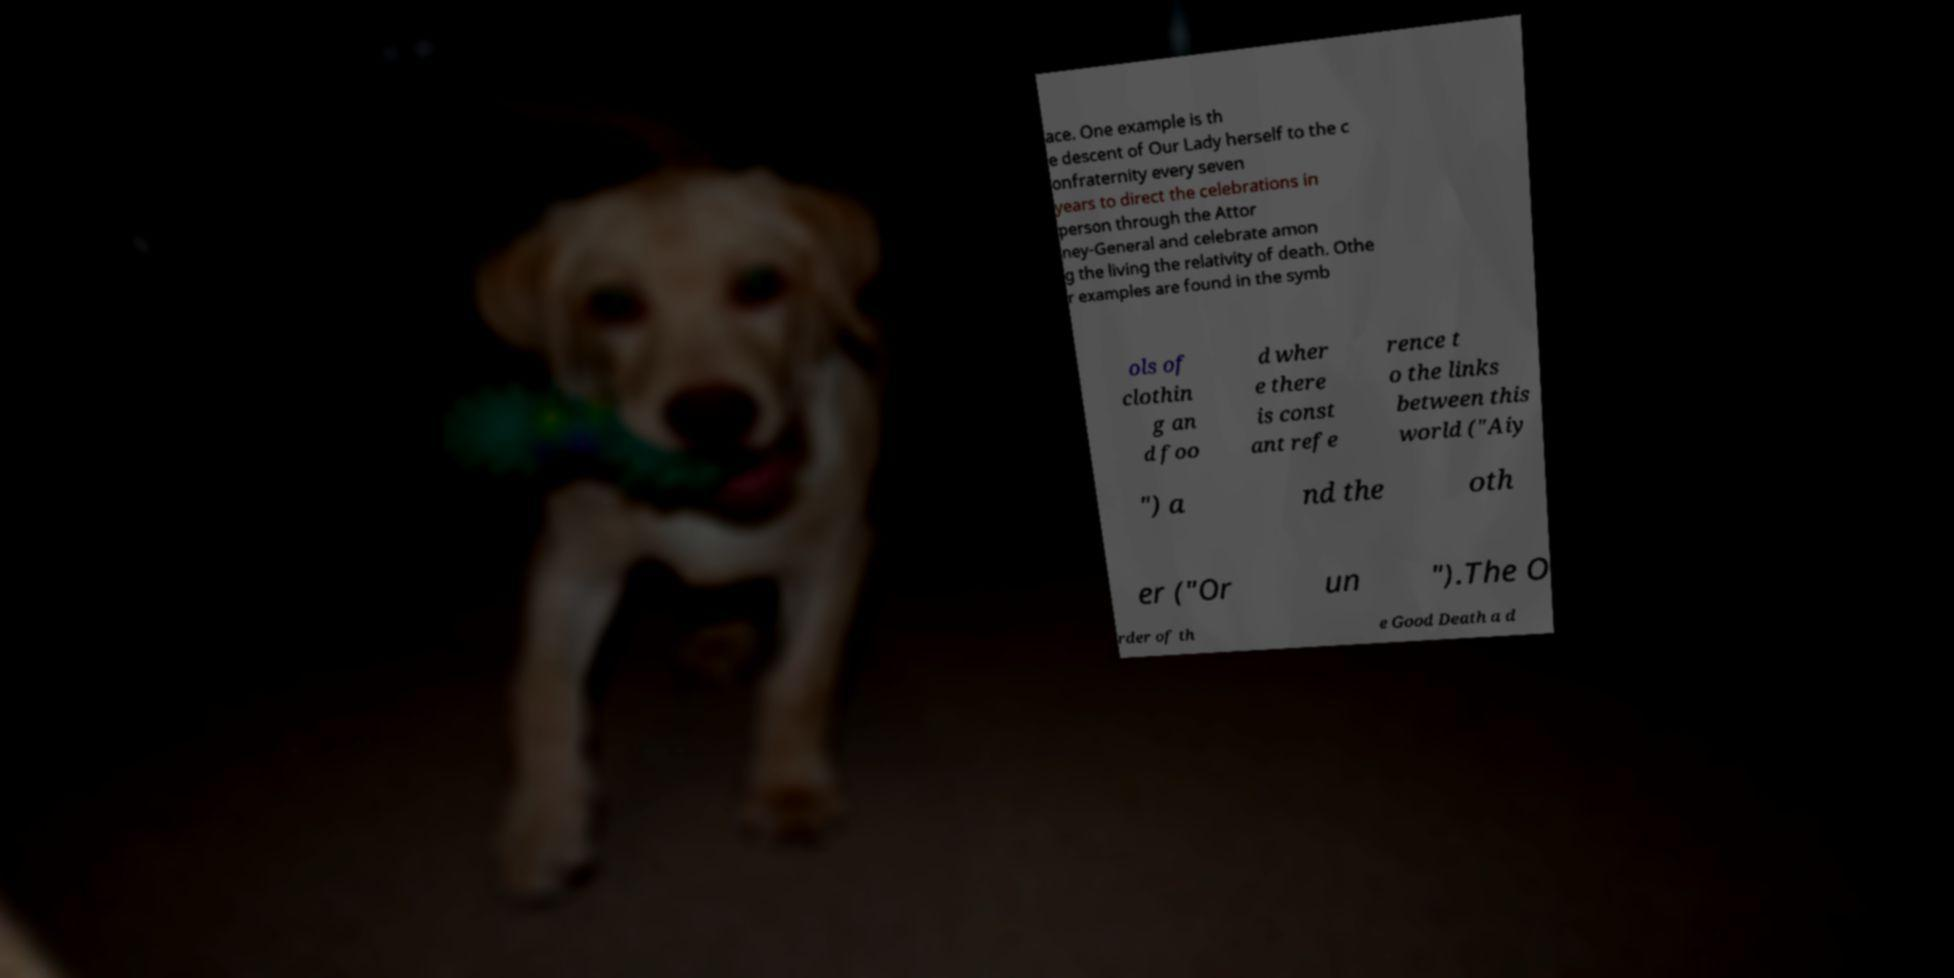Could you extract and type out the text from this image? ace. One example is th e descent of Our Lady herself to the c onfraternity every seven years to direct the celebrations in person through the Attor ney-General and celebrate amon g the living the relativity of death. Othe r examples are found in the symb ols of clothin g an d foo d wher e there is const ant refe rence t o the links between this world ("Aiy ") a nd the oth er ("Or un ").The O rder of th e Good Death a d 